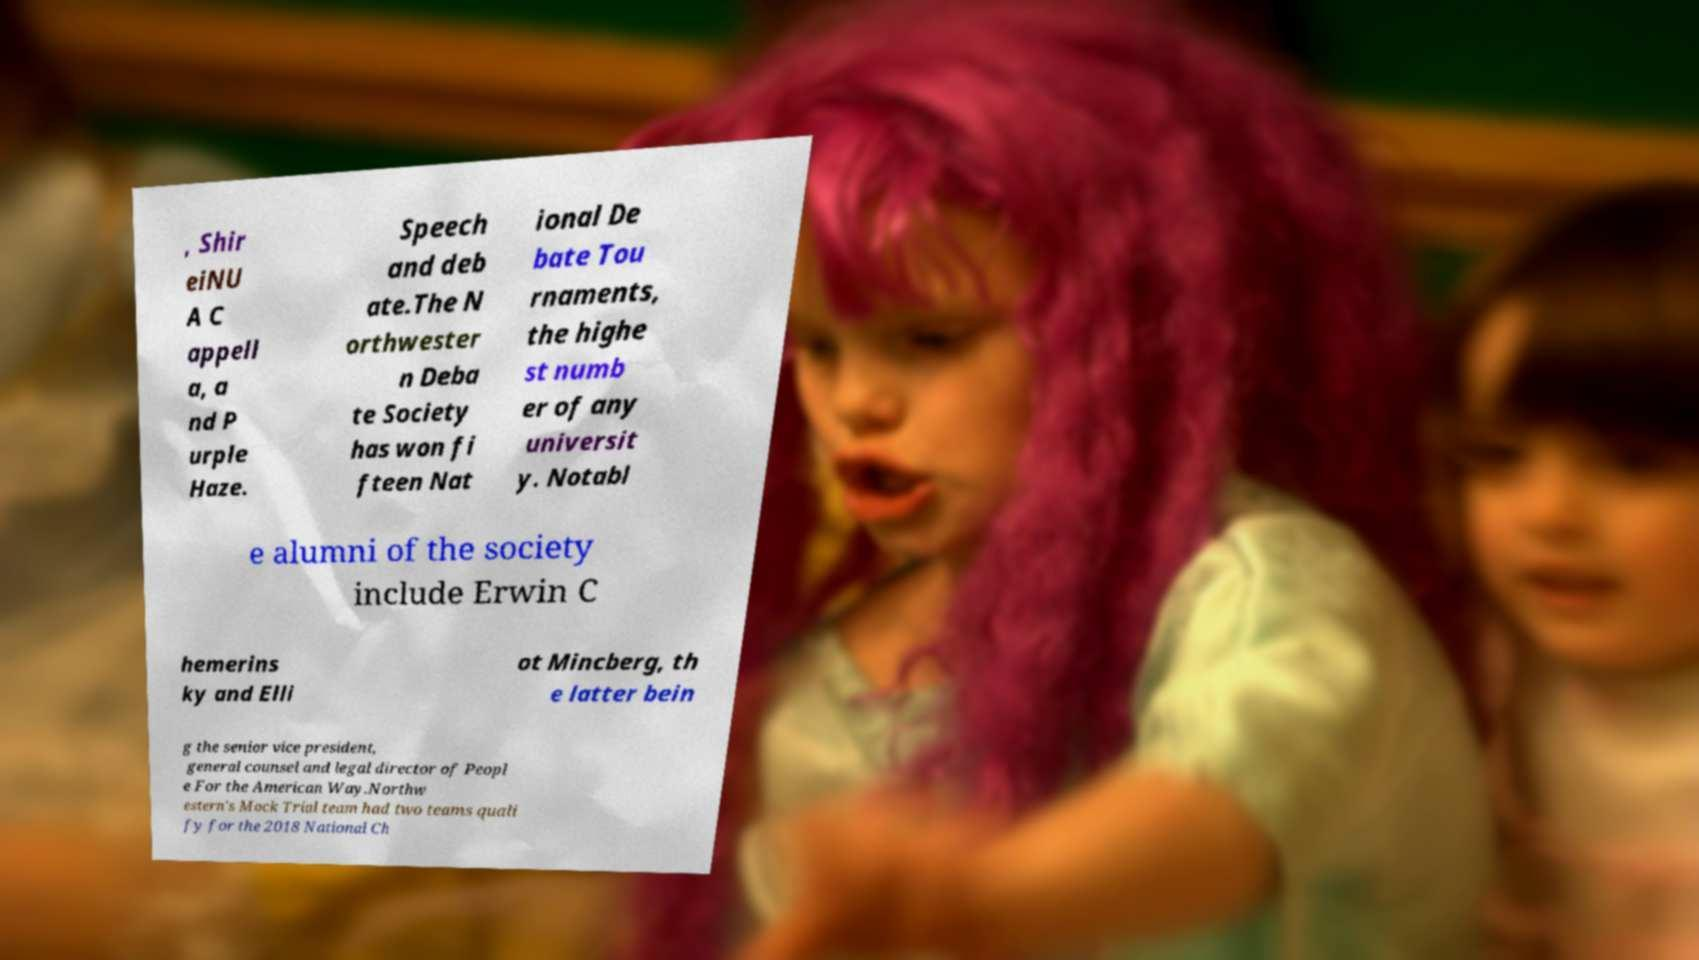There's text embedded in this image that I need extracted. Can you transcribe it verbatim? , Shir eiNU A C appell a, a nd P urple Haze. Speech and deb ate.The N orthwester n Deba te Society has won fi fteen Nat ional De bate Tou rnaments, the highe st numb er of any universit y. Notabl e alumni of the society include Erwin C hemerins ky and Elli ot Mincberg, th e latter bein g the senior vice president, general counsel and legal director of Peopl e For the American Way.Northw estern's Mock Trial team had two teams quali fy for the 2018 National Ch 